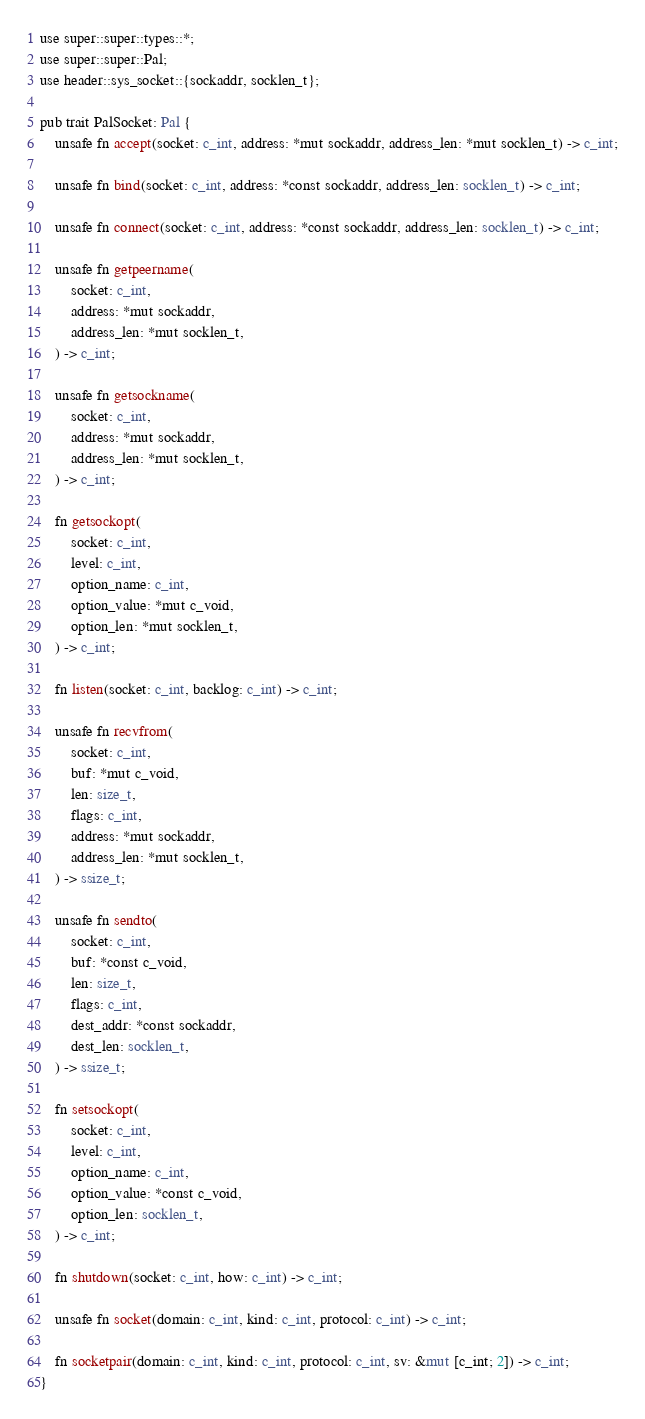<code> <loc_0><loc_0><loc_500><loc_500><_Rust_>use super::super::types::*;
use super::super::Pal;
use header::sys_socket::{sockaddr, socklen_t};

pub trait PalSocket: Pal {
    unsafe fn accept(socket: c_int, address: *mut sockaddr, address_len: *mut socklen_t) -> c_int;

    unsafe fn bind(socket: c_int, address: *const sockaddr, address_len: socklen_t) -> c_int;

    unsafe fn connect(socket: c_int, address: *const sockaddr, address_len: socklen_t) -> c_int;

    unsafe fn getpeername(
        socket: c_int,
        address: *mut sockaddr,
        address_len: *mut socklen_t,
    ) -> c_int;

    unsafe fn getsockname(
        socket: c_int,
        address: *mut sockaddr,
        address_len: *mut socklen_t,
    ) -> c_int;

    fn getsockopt(
        socket: c_int,
        level: c_int,
        option_name: c_int,
        option_value: *mut c_void,
        option_len: *mut socklen_t,
    ) -> c_int;

    fn listen(socket: c_int, backlog: c_int) -> c_int;

    unsafe fn recvfrom(
        socket: c_int,
        buf: *mut c_void,
        len: size_t,
        flags: c_int,
        address: *mut sockaddr,
        address_len: *mut socklen_t,
    ) -> ssize_t;

    unsafe fn sendto(
        socket: c_int,
        buf: *const c_void,
        len: size_t,
        flags: c_int,
        dest_addr: *const sockaddr,
        dest_len: socklen_t,
    ) -> ssize_t;

    fn setsockopt(
        socket: c_int,
        level: c_int,
        option_name: c_int,
        option_value: *const c_void,
        option_len: socklen_t,
    ) -> c_int;

    fn shutdown(socket: c_int, how: c_int) -> c_int;

    unsafe fn socket(domain: c_int, kind: c_int, protocol: c_int) -> c_int;

    fn socketpair(domain: c_int, kind: c_int, protocol: c_int, sv: &mut [c_int; 2]) -> c_int;
}
</code> 